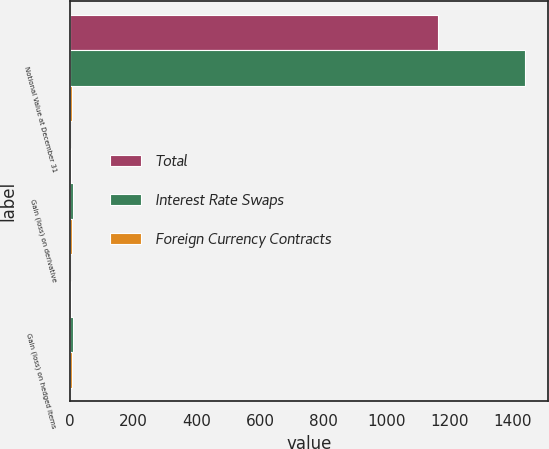Convert chart to OTSL. <chart><loc_0><loc_0><loc_500><loc_500><stacked_bar_chart><ecel><fcel>Notional Value at December 31<fcel>Gain (loss) on derivative<fcel>Gain (loss) on hedged items<nl><fcel>Total<fcel>1163<fcel>3<fcel>3<nl><fcel>Interest Rate Swaps<fcel>1438<fcel>8<fcel>8<nl><fcel>Foreign Currency Contracts<fcel>6.5<fcel>5<fcel>5<nl></chart> 